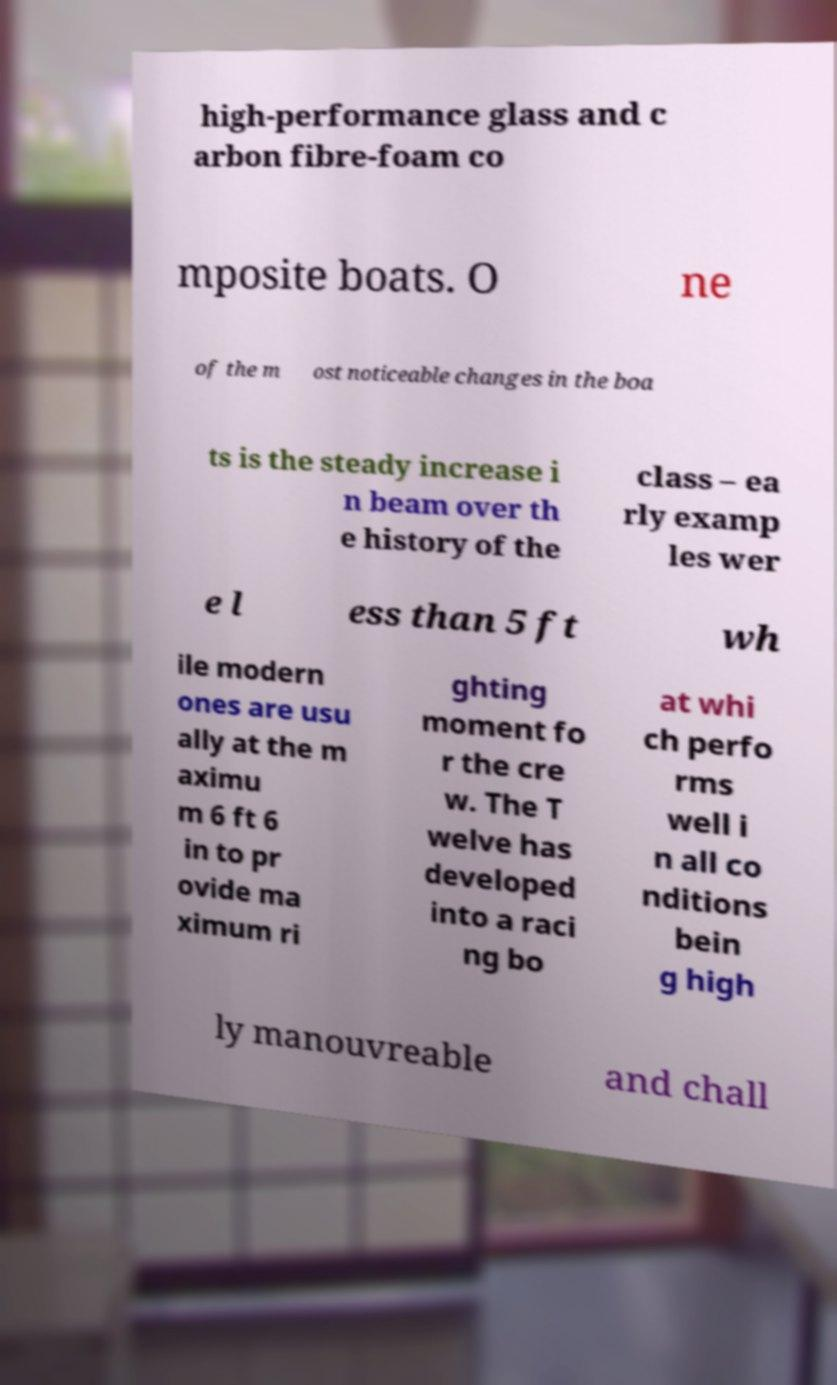For documentation purposes, I need the text within this image transcribed. Could you provide that? high-performance glass and c arbon fibre-foam co mposite boats. O ne of the m ost noticeable changes in the boa ts is the steady increase i n beam over th e history of the class – ea rly examp les wer e l ess than 5 ft wh ile modern ones are usu ally at the m aximu m 6 ft 6 in to pr ovide ma ximum ri ghting moment fo r the cre w. The T welve has developed into a raci ng bo at whi ch perfo rms well i n all co nditions bein g high ly manouvreable and chall 